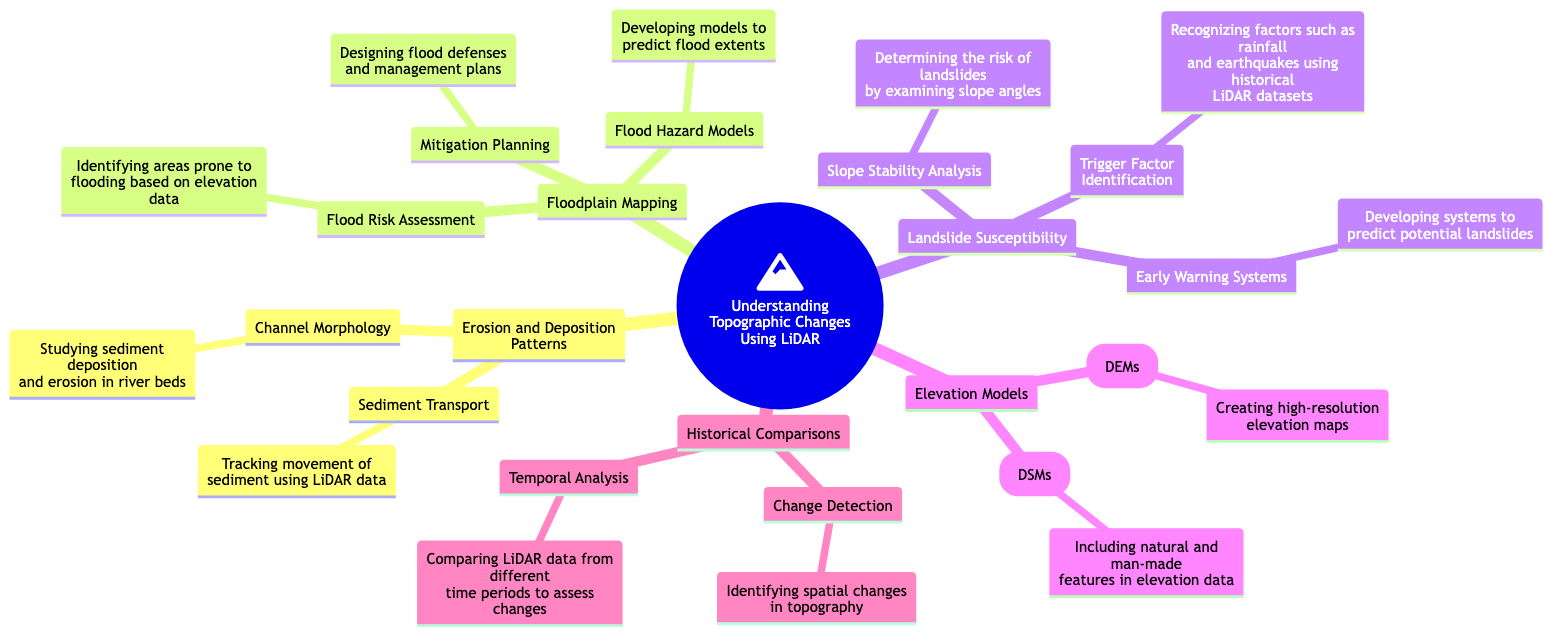What are the primary branches in the concept map? The primary branches can be identified by looking at the main categories stemming from the central node, which include Erosion and Deposition Patterns, Floodplain Mapping, Landslide Susceptibility, Elevation Models, and Historical Comparisons.
Answer: Erosion and Deposition Patterns, Floodplain Mapping, Landslide Susceptibility, Elevation Models, Historical Comparisons How many sub-branches are there under Floodplain Mapping? To determine the number of sub-branches under Floodplain Mapping, one can count the items listed under that category. There are three sub-branches: Flood Risk Assessment, Flood Hazard Models, and Mitigation Planning.
Answer: 3 What is the focus of the sub-branch related to Slope Stability Analysis? Looking at the details provided under Slope Stability Analysis, it is focused on determining the risk of landslides by examining slope angles.
Answer: Determining the risk of landslides by examining slope angles What is the relationship between Sediment Transport and Erosion and Deposition Patterns? Sediment Transport is a sub-branch under the primary branch Erosion and Deposition Patterns, indicating that it is a specific aspect or part of studying erosion and deposition processes.
Answer: It is a sub-branch What is the purpose of Early Warning Systems in the context of Landslide Susceptibility? Early Warning Systems aim to develop systems that can predict potential landslides, thereby serving a crucial function in landslide risk mitigation.
Answer: To predict potential landslides How does Change Detection relate to Historical Comparisons? Change Detection is listed as a sub-branch under Historical Comparisons, meaning it involves identifying spatial changes in topography over time, which is a fundamental aspect of comparing historical data.
Answer: Identifying spatial changes in topography What do Digital Elevation Models (DEMs) focus on? Digital Elevation Models (DEMs) are focused on creating high-resolution elevation maps, which provides detailed terrain information.
Answer: Creating high-resolution elevation maps Which sub-branch of Floodplain Mapping addresses the design of flood defenses? The sub-branch that addresses the design of flood defenses is Mitigation Planning, which directly involves planning for flood management strategies.
Answer: Mitigation Planning What type of data is used for Trigger Factor Identification? Trigger Factor Identification uses historical LiDAR datasets to recognize factors that may lead to landslides, such as rainfall and earthquakes.
Answer: Historical LiDAR datasets 